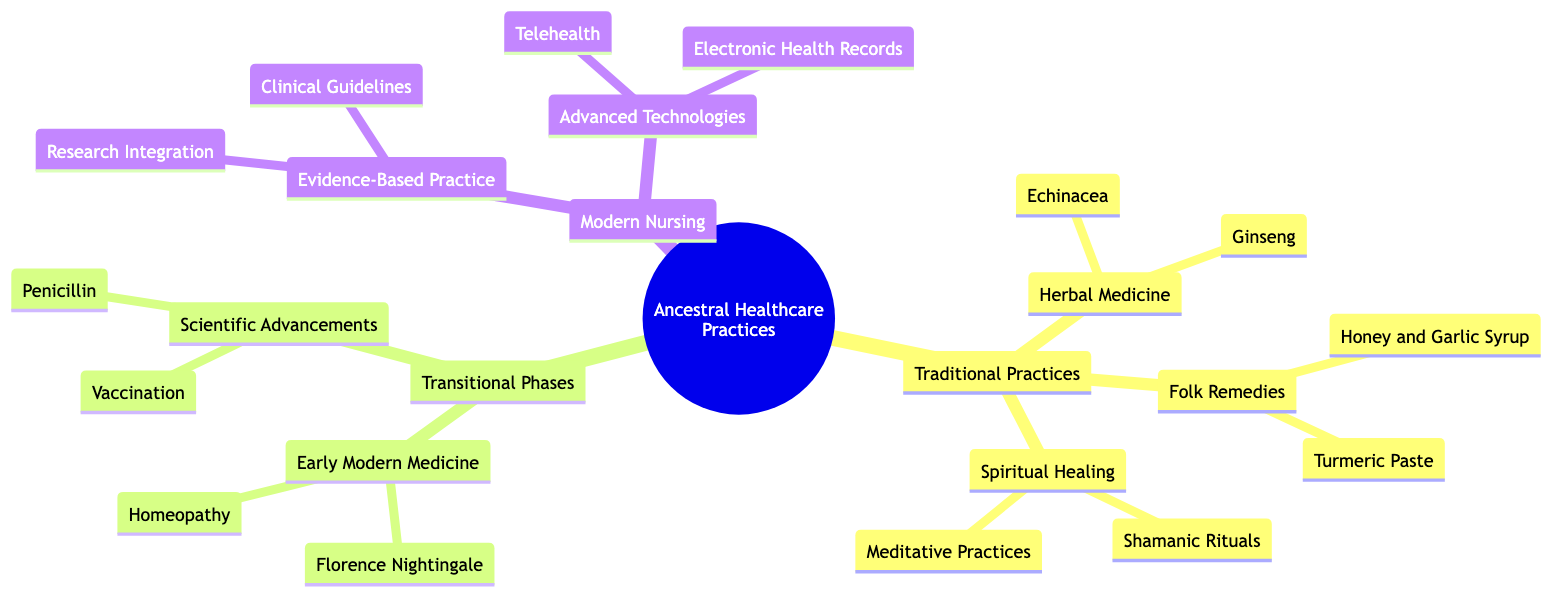What are the three main categories in the family tree? The diagram lists three main categories: Traditional Practices, Transitional Phases, and Modern Nursing. These categories encompass the evolution of healthcare practices.
Answer: Traditional Practices, Transitional Phases, Modern Nursing How many entities are listed under Herbal Medicine? The diagram indicates that there are two entities under Herbal Medicine: Echinacea and Ginseng. This can be counted by examining the nodes under the Herbal Medicine category.
Answer: 2 Which traditional practice is associated with respiratory ailments? The entity Honey and Garlic Syrup is found under the Folk Remedies category and is specifically indicated for respiratory ailments. This is determined by looking at the entities listed under Folk Remedies.
Answer: Honey and Garlic Syrup Who is recognized as the founder of modern nursing? Florence Nightingale is listed as a key figure under Early Modern Medicine in the diagram, identifying her as the founder of modern nursing. This information can be directly extracted from the Early Modern Medicine node.
Answer: Florence Nightingale What is a key feature of Evidence-Based Practice in Modern Nursing? Research Integration is a key feature under Evidence-Based Practice, focusing on using current best evidence in patient care. This can be seen in the Modern Nursing section.
Answer: Research Integration How many entities are listed under Spiritual Healing? There are two entities listed under Spiritual Healing: Shamanic Rituals and Meditative Practices. This count can be made by reviewing the entities beneath the Spiritual Healing category.
Answer: 2 What advancement revolutionized the treatment of bacterial infections? Penicillin, discovered by Alexander Fleming, is identified as a key advancement under Scientific Advancements, revolutionizing bacterial infection treatment. This is mentioned in the Scientific Advancements section of the diagram.
Answer: Penicillin Which modern technology facilitates remote patient care? Telehealth is the technology listed under Advanced Technologies that facilitates remote patient care. This is directly described in the Modern Nursing section of the family tree.
Answer: Telehealth 